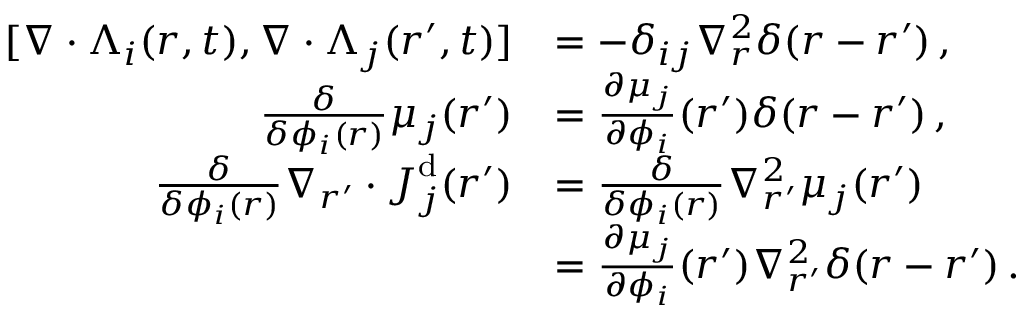Convert formula to latex. <formula><loc_0><loc_0><loc_500><loc_500>\begin{array} { r l } { [ \nabla \cdot { \Lambda } _ { i } ( { r } , t ) , \nabla \cdot { \Lambda } _ { j } ( { r } ^ { \prime } , t ) ] } & { = - \delta _ { i j } \nabla _ { r } ^ { 2 } \delta ( { r } - { r } ^ { \prime } ) \, , } \\ { \frac { \delta } { \delta \phi _ { i } ( { r } ) } \mu _ { j } ( { r } ^ { \prime } ) } & { = \frac { \partial \mu _ { j } } { \partial \phi _ { i } } ( { r } ^ { \prime } ) \delta ( { r } - { r } ^ { \prime } ) \, , } \\ { \frac { \delta } { \delta \phi _ { i } ( { r } ) } \nabla _ { { r } ^ { \prime } } \cdot { J } _ { j } ^ { d } ( { r } ^ { \prime } ) } & { = \frac { \delta } { \delta \phi _ { i } ( { r } ) } \nabla _ { { r } ^ { \prime } } ^ { 2 } \mu _ { j } ( { r } ^ { \prime } ) } \\ & { = \frac { \partial \mu _ { j } } { \partial \phi _ { i } } ( { r } ^ { \prime } ) \nabla _ { { r } ^ { \prime } } ^ { 2 } \delta ( { r } - { r } ^ { \prime } ) \, . } \end{array}</formula> 